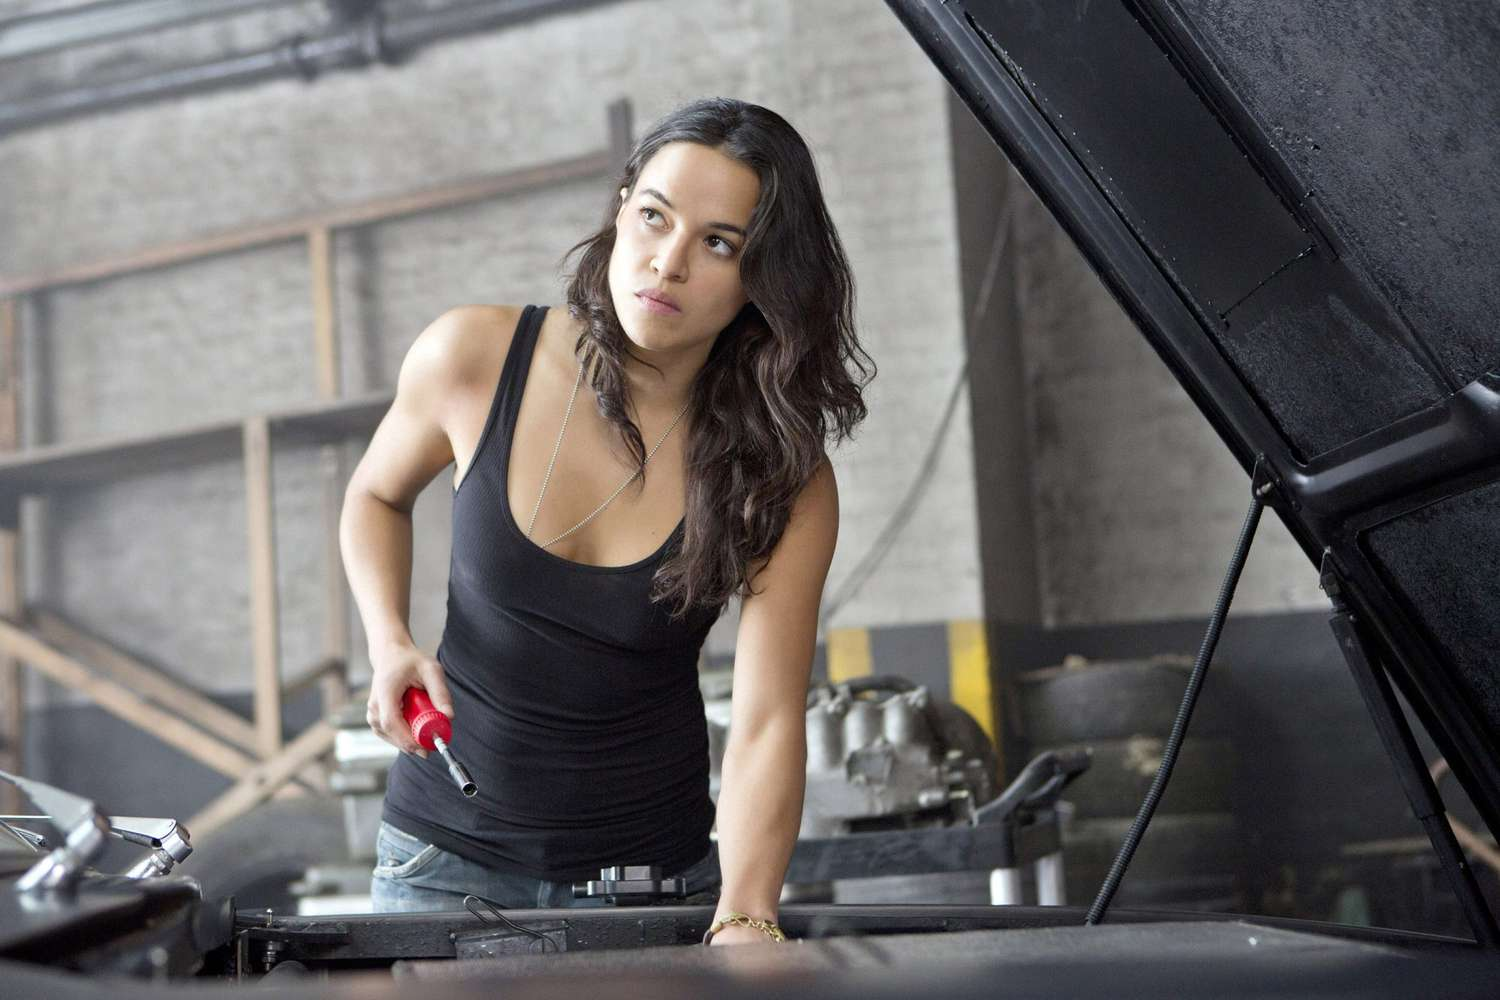Create a whimsical, imaginative story inspired by the image. In a magical twist, the garage transforms into an enchanted workshop as dusk falls. The woman discovers that the tools come to life, and the car she is working on is no ordinary vehicle—it’s an ancient chariot imbued with mystical powers. She is not just a mechanic but a guardian of this magical artifact. As she tightens the last bolt, the car begins to shimmer, revealing its true form. Suddenly, mythical creatures roam the workshop, aiding her in preparing for an epic journey through enchanted forests and over mystical mountains. Her mission is to deliver the chariot to the guardians of the realm before the full moon, safeguarding the balance of magical energies in their world. 